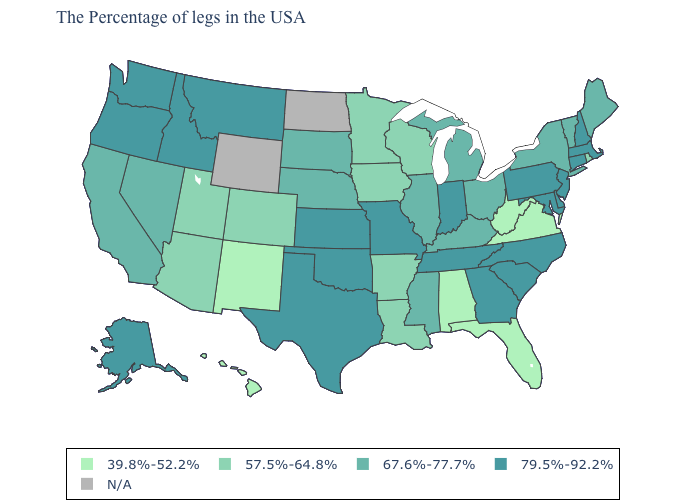Does the map have missing data?
Keep it brief. Yes. Which states hav the highest value in the West?
Concise answer only. Montana, Idaho, Washington, Oregon, Alaska. What is the lowest value in states that border Kentucky?
Be succinct. 39.8%-52.2%. What is the highest value in the West ?
Be succinct. 79.5%-92.2%. What is the lowest value in the USA?
Concise answer only. 39.8%-52.2%. Which states have the lowest value in the Northeast?
Concise answer only. Rhode Island. Name the states that have a value in the range 57.5%-64.8%?
Keep it brief. Rhode Island, Wisconsin, Louisiana, Arkansas, Minnesota, Iowa, Colorado, Utah, Arizona. Name the states that have a value in the range 67.6%-77.7%?
Be succinct. Maine, Vermont, New York, Ohio, Michigan, Kentucky, Illinois, Mississippi, Nebraska, South Dakota, Nevada, California. Name the states that have a value in the range 67.6%-77.7%?
Give a very brief answer. Maine, Vermont, New York, Ohio, Michigan, Kentucky, Illinois, Mississippi, Nebraska, South Dakota, Nevada, California. Which states have the lowest value in the Northeast?
Answer briefly. Rhode Island. Name the states that have a value in the range 67.6%-77.7%?
Answer briefly. Maine, Vermont, New York, Ohio, Michigan, Kentucky, Illinois, Mississippi, Nebraska, South Dakota, Nevada, California. 